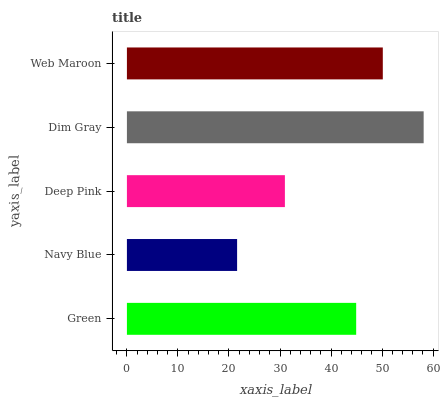Is Navy Blue the minimum?
Answer yes or no. Yes. Is Dim Gray the maximum?
Answer yes or no. Yes. Is Deep Pink the minimum?
Answer yes or no. No. Is Deep Pink the maximum?
Answer yes or no. No. Is Deep Pink greater than Navy Blue?
Answer yes or no. Yes. Is Navy Blue less than Deep Pink?
Answer yes or no. Yes. Is Navy Blue greater than Deep Pink?
Answer yes or no. No. Is Deep Pink less than Navy Blue?
Answer yes or no. No. Is Green the high median?
Answer yes or no. Yes. Is Green the low median?
Answer yes or no. Yes. Is Deep Pink the high median?
Answer yes or no. No. Is Web Maroon the low median?
Answer yes or no. No. 